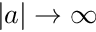<formula> <loc_0><loc_0><loc_500><loc_500>| a | \to \infty</formula> 